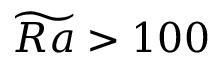Convert formula to latex. <formula><loc_0><loc_0><loc_500><loc_500>\widetilde { R a } > 1 0 0</formula> 